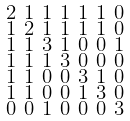Convert formula to latex. <formula><loc_0><loc_0><loc_500><loc_500>\begin{smallmatrix} 2 & 1 & 1 & 1 & 1 & 1 & 0 \\ 1 & 2 & 1 & 1 & 1 & 1 & 0 \\ 1 & 1 & 3 & 1 & 0 & 0 & 1 \\ 1 & 1 & 1 & 3 & 0 & 0 & 0 \\ 1 & 1 & 0 & 0 & 3 & 1 & 0 \\ 1 & 1 & 0 & 0 & 1 & 3 & 0 \\ 0 & 0 & 1 & 0 & 0 & 0 & 3 \end{smallmatrix}</formula> 